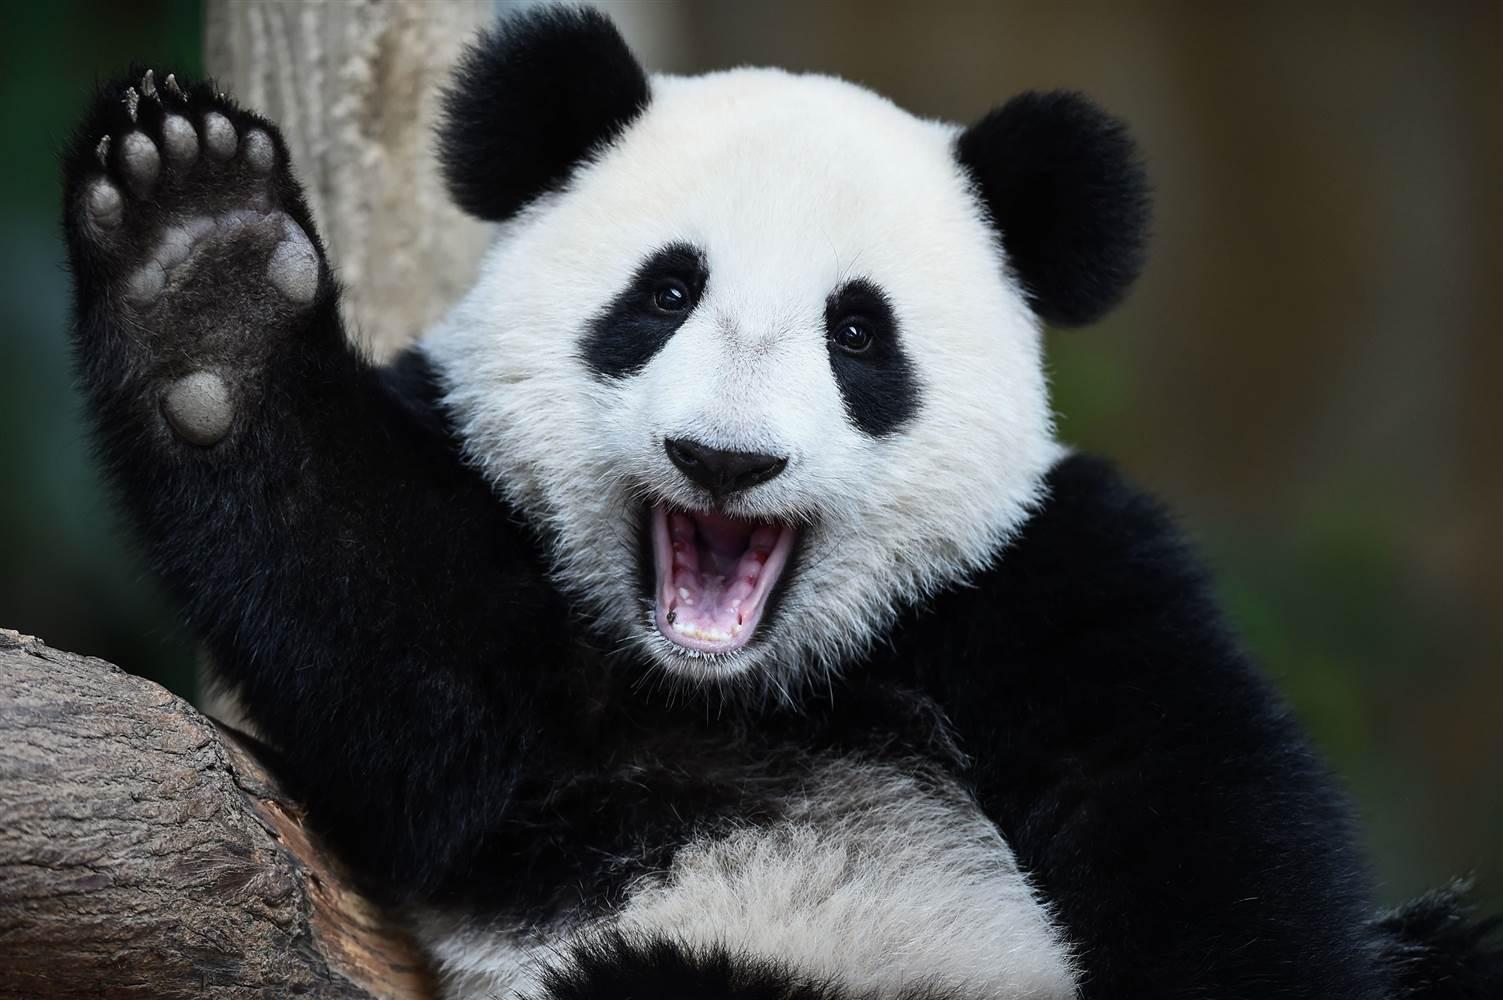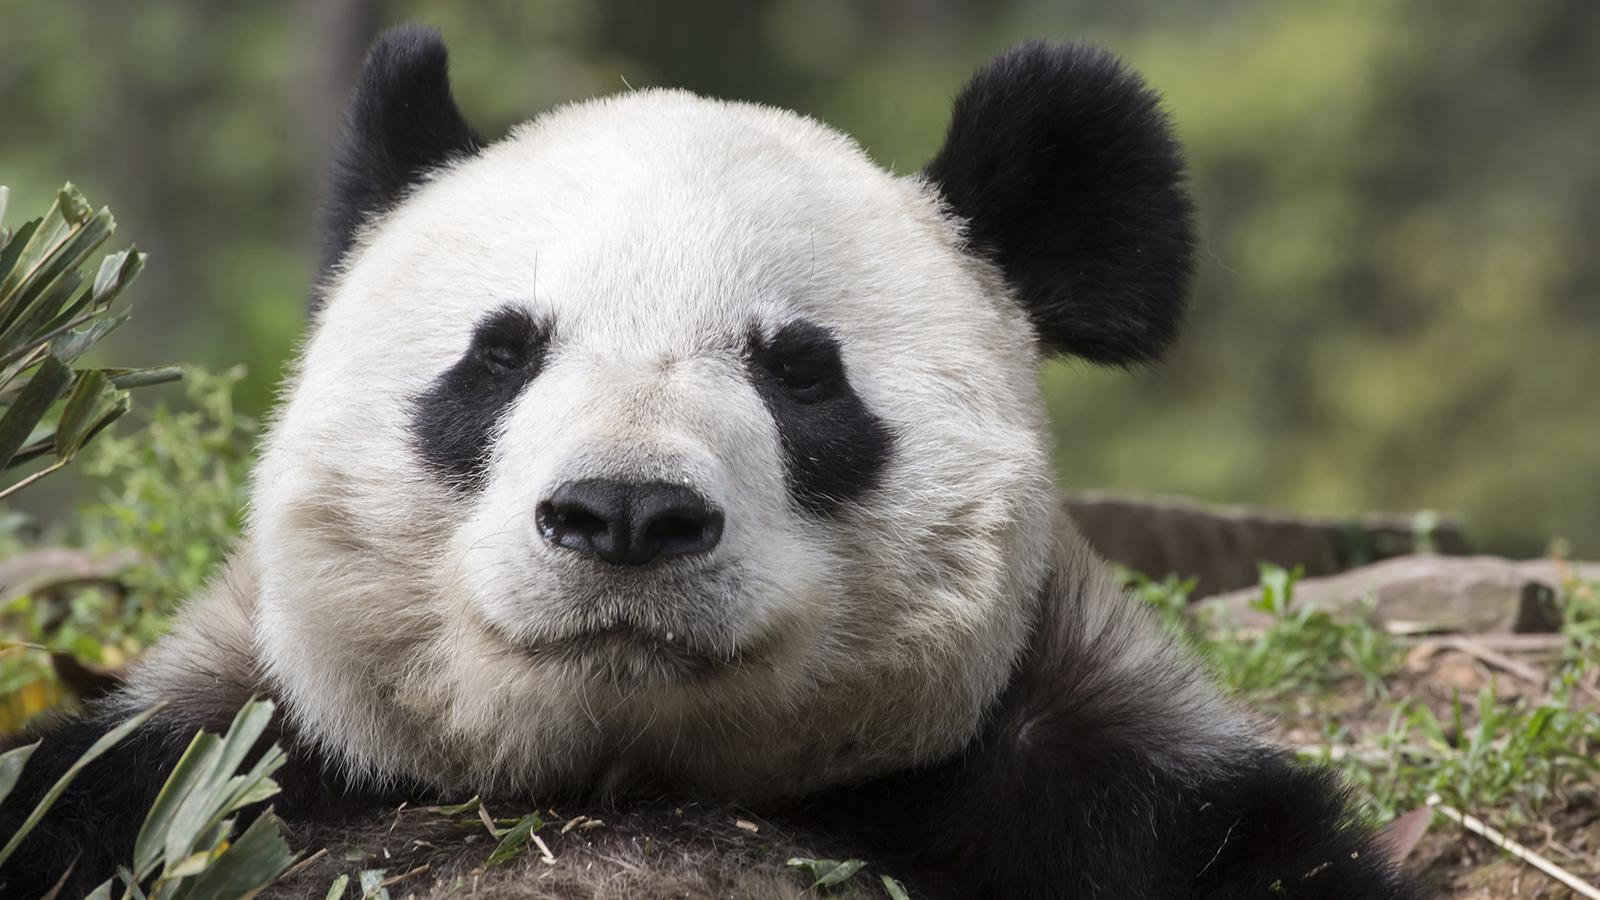The first image is the image on the left, the second image is the image on the right. Considering the images on both sides, is "The panda in the right image has paws on a branch." valid? Answer yes or no. No. The first image is the image on the left, the second image is the image on the right. Analyze the images presented: Is the assertion "There is exactly one panda with all feet on the ground in one of the images" valid? Answer yes or no. No. 